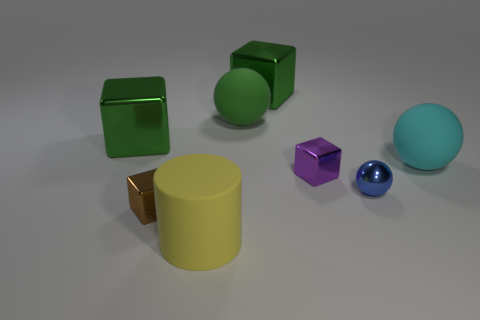Subtract all big spheres. How many spheres are left? 1 Subtract all brown cylinders. How many green cubes are left? 2 Add 1 tiny purple rubber cylinders. How many objects exist? 9 Subtract all cylinders. How many objects are left? 7 Subtract all purple blocks. How many blocks are left? 3 Subtract 1 balls. How many balls are left? 2 Add 3 large cyan things. How many large cyan things exist? 4 Subtract 0 brown spheres. How many objects are left? 8 Subtract all gray blocks. Subtract all purple balls. How many blocks are left? 4 Subtract all large green metal things. Subtract all big cylinders. How many objects are left? 5 